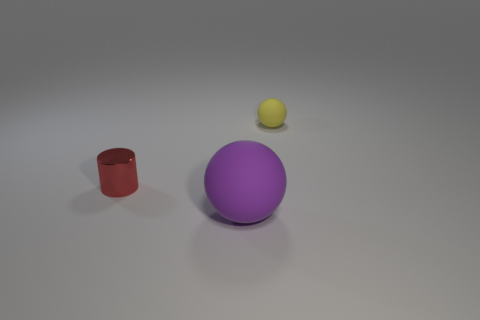Subtract all purple spheres. How many spheres are left? 1 Add 3 big red rubber things. How many objects exist? 6 Subtract all gray balls. Subtract all red cubes. How many balls are left? 2 Subtract all gray blocks. How many purple spheres are left? 1 Subtract all cylinders. Subtract all cylinders. How many objects are left? 1 Add 2 small matte spheres. How many small matte spheres are left? 3 Add 2 large red shiny objects. How many large red shiny objects exist? 2 Subtract 0 brown blocks. How many objects are left? 3 Subtract all cylinders. How many objects are left? 2 Subtract 1 cylinders. How many cylinders are left? 0 